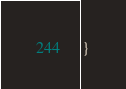Convert code to text. <code><loc_0><loc_0><loc_500><loc_500><_JavaScript_>}

</code> 